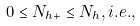Convert formula to latex. <formula><loc_0><loc_0><loc_500><loc_500>0 \leq N _ { h + } \leq N _ { h } , i . e . ,</formula> 